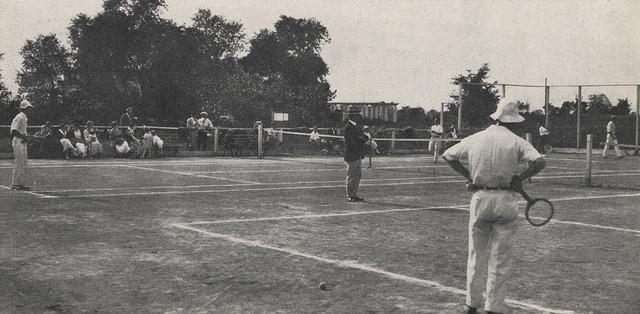How many people are there?
Give a very brief answer. 2. 